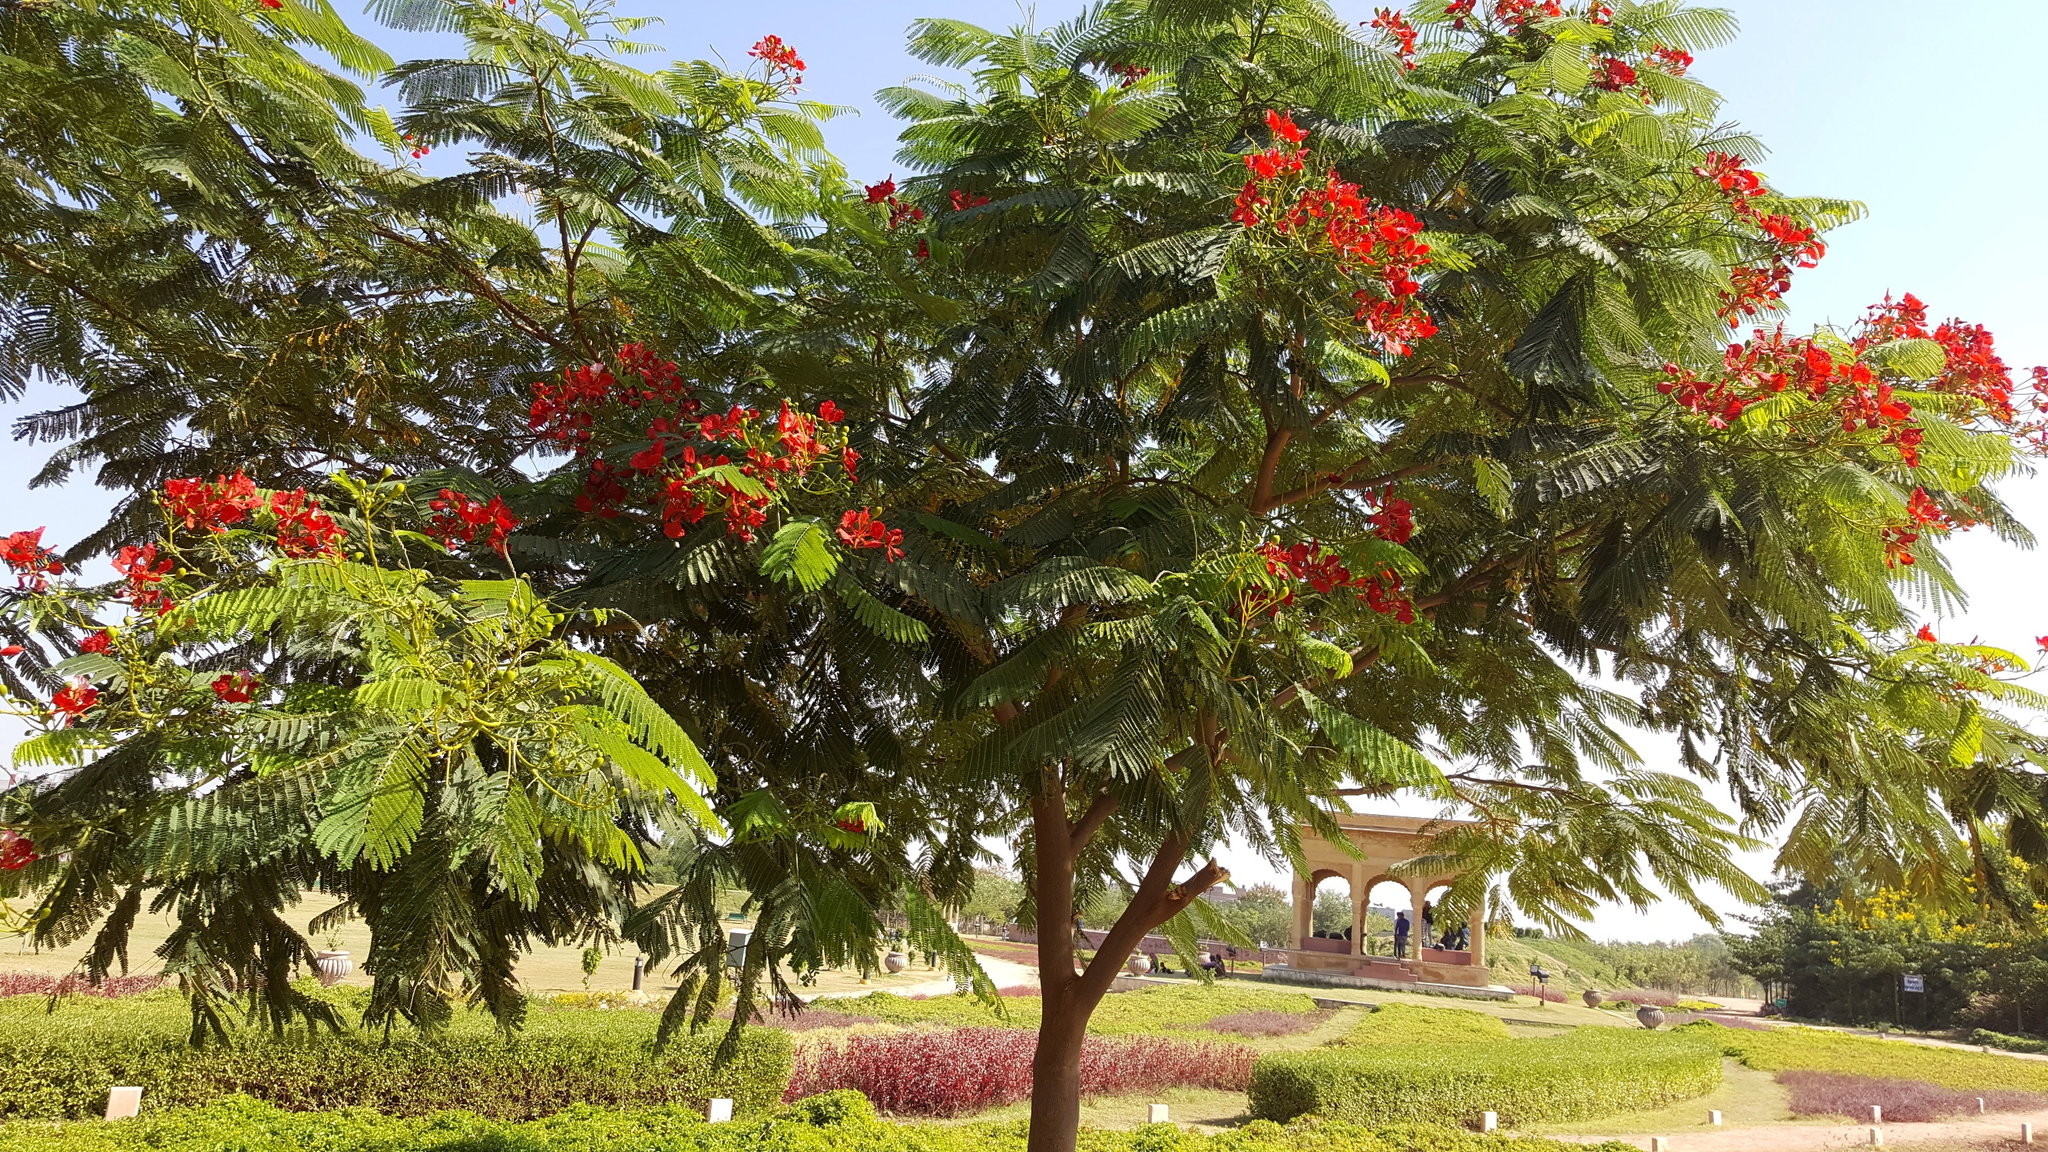What are the key elements in this picture?
 This is a captivating image of a tree in a park. The tree, which is the main subject of the image, is adorned with vibrant red flowers, contrasting beautifully with its lush green leaves. It stands in the foreground, drawing the viewer's attention immediately. 

The park in the background adds depth to the image. A gazebo and a path can be seen, inviting viewers to imagine themselves strolling through the park. The grass is a rich green, typical of a well-maintained park.

The sky above is a clear blue, suggesting a bright, sunny day. The perspective of the image is from the ground looking up at the tree, giving a sense of the tree's height and majesty. 

Unfortunately, I couldn't find any specific information about the landmark "sa_17289". The image doesn't provide enough details to confidently identify the exact location of this park. However, the beauty of the scene is universal and can be appreciated regardless of its specific geographical location. 